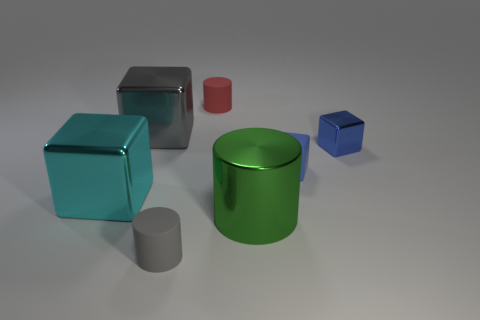What number of things are tiny yellow rubber cubes or cylinders that are behind the large green thing?
Give a very brief answer. 1. What material is the large block that is to the left of the gray thing behind the matte cylinder to the left of the red rubber cylinder made of?
Your response must be concise. Metal. Is there anything else that is made of the same material as the green cylinder?
Offer a very short reply. Yes. There is a metallic cube on the right side of the big gray thing; does it have the same color as the tiny matte block?
Keep it short and to the point. Yes. What number of gray things are either large metal cylinders or cylinders?
Give a very brief answer. 1. What number of other things are there of the same shape as the cyan metallic thing?
Your answer should be compact. 3. Is the big cyan thing made of the same material as the large green object?
Offer a very short reply. Yes. What is the material of the object that is behind the blue matte cube and on the right side of the big green thing?
Give a very brief answer. Metal. There is a big metallic thing that is behind the large cyan thing; what is its color?
Your answer should be compact. Gray. Is the number of tiny red rubber things behind the small blue shiny object greater than the number of purple rubber things?
Ensure brevity in your answer.  Yes. 